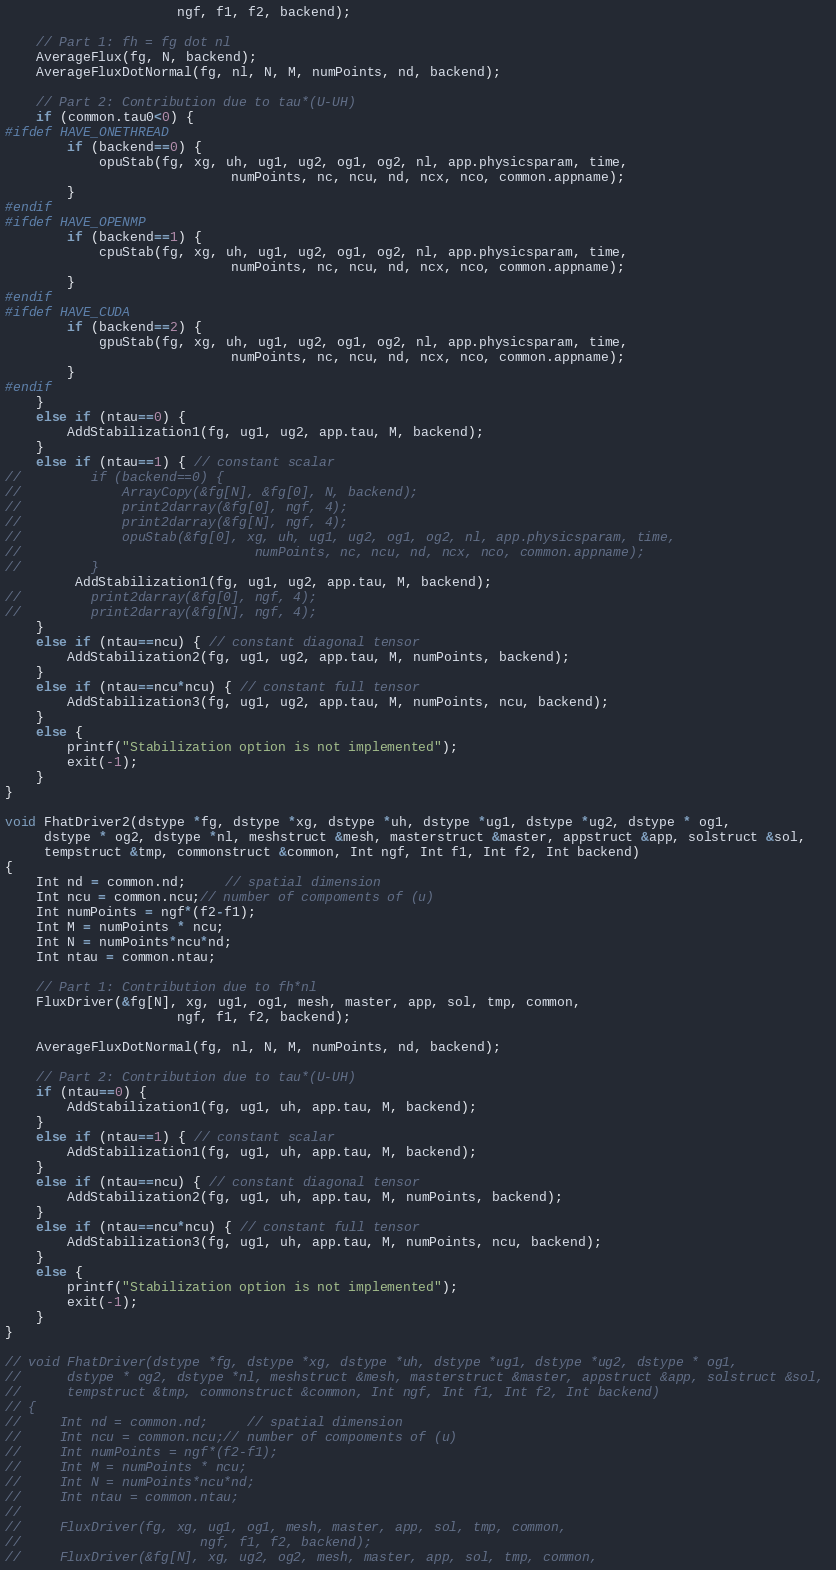<code> <loc_0><loc_0><loc_500><loc_500><_C++_>                      ngf, f1, f2, backend);        
    
    // Part 1: fh = fg dot nl
    AverageFlux(fg, N, backend);    
    AverageFluxDotNormal(fg, nl, N, M, numPoints, nd, backend);            

    // Part 2: Contribution due to tau*(U-UH)    
    if (common.tau0<0) { 
#ifdef HAVE_ONETHREAD            
        if (backend==0) {
            opuStab(fg, xg, uh, ug1, ug2, og1, og2, nl, app.physicsparam, time, 
                             numPoints, nc, ncu, nd, ncx, nco, common.appname);
        }
#endif              
#ifdef HAVE_OPENMP                        
        if (backend==1) {
            cpuStab(fg, xg, uh, ug1, ug2, og1, og2, nl, app.physicsparam, time, 
                             numPoints, nc, ncu, nd, ncx, nco, common.appname);
        }
#endif            
#ifdef HAVE_CUDA                             
        if (backend==2) {
            gpuStab(fg, xg, uh, ug1, ug2, og1, og2, nl, app.physicsparam, time, 
                             numPoints, nc, ncu, nd, ncx, nco, common.appname);
        }
#endif                            
    }
    else if (ntau==0) {          
        AddStabilization1(fg, ug1, ug2, app.tau, M, backend);
    }
    else if (ntau==1) { // constant scalar  
//         if (backend==0) {            
//             ArrayCopy(&fg[N], &fg[0], N, backend);
//             print2darray(&fg[0], ngf, 4);
//             print2darray(&fg[N], ngf, 4);
//             opuStab(&fg[0], xg, uh, ug1, ug2, og1, og2, nl, app.physicsparam, time, 
//                              numPoints, nc, ncu, nd, ncx, nco, common.appname);
//         }            
         AddStabilization1(fg, ug1, ug2, app.tau, M, backend);
//         print2darray(&fg[0], ngf, 4);
//         print2darray(&fg[N], ngf, 4);        
    }
    else if (ntau==ncu) { // constant diagonal tensor
        AddStabilization2(fg, ug1, ug2, app.tau, M, numPoints, backend);
    }
    else if (ntau==ncu*ncu) { // constant full tensor      
        AddStabilization3(fg, ug1, ug2, app.tau, M, numPoints, ncu, backend);
    }
    else {
        printf("Stabilization option is not implemented");
        exit(-1);
    }            
}

void FhatDriver2(dstype *fg, dstype *xg, dstype *uh, dstype *ug1, dstype *ug2, dstype * og1, 
     dstype * og2, dstype *nl, meshstruct &mesh, masterstruct &master, appstruct &app, solstruct &sol, 
     tempstruct &tmp, commonstruct &common, Int ngf, Int f1, Int f2, Int backend)
{
    Int nd = common.nd;     // spatial dimension       
    Int ncu = common.ncu;// number of compoments of (u)
    Int numPoints = ngf*(f2-f1);
    Int M = numPoints * ncu;
    Int N = numPoints*ncu*nd;
    Int ntau = common.ntau;
    
    // Part 1: Contribution due to fh*nl    
    FluxDriver(&fg[N], xg, ug1, og1, mesh, master, app, sol, tmp, common,
                      ngf, f1, f2, backend);
    
    AverageFluxDotNormal(fg, nl, N, M, numPoints, nd, backend);

    // Part 2: Contribution due to tau*(U-UH)
    if (ntau==0) { 
        AddStabilization1(fg, ug1, uh, app.tau, M, backend);
    }
    else if (ntau==1) { // constant scalar  
        AddStabilization1(fg, ug1, uh, app.tau, M, backend);
    }
    else if (ntau==ncu) { // constant diagonal tensor
        AddStabilization2(fg, ug1, uh, app.tau, M, numPoints, backend);
    }
    else if (ntau==ncu*ncu) { // constant full tensor      
        AddStabilization3(fg, ug1, uh, app.tau, M, numPoints, ncu, backend);
    }
    else {
        printf("Stabilization option is not implemented");
        exit(-1);
    }
}

// void FhatDriver(dstype *fg, dstype *xg, dstype *uh, dstype *ug1, dstype *ug2, dstype * og1, 
//      dstype * og2, dstype *nl, meshstruct &mesh, masterstruct &master, appstruct &app, solstruct &sol, 
//      tempstruct &tmp, commonstruct &common, Int ngf, Int f1, Int f2, Int backend)
// {
//     Int nd = common.nd;     // spatial dimension       
//     Int ncu = common.ncu;// number of compoments of (u)
//     Int numPoints = ngf*(f2-f1);
//     Int M = numPoints * ncu;
//     Int N = numPoints*ncu*nd;
//     Int ntau = common.ntau;
//     
//     FluxDriver(fg, xg, ug1, og1, mesh, master, app, sol, tmp, common,
//                       ngf, f1, f2, backend);
//     FluxDriver(&fg[N], xg, ug2, og2, mesh, master, app, sol, tmp, common,</code> 